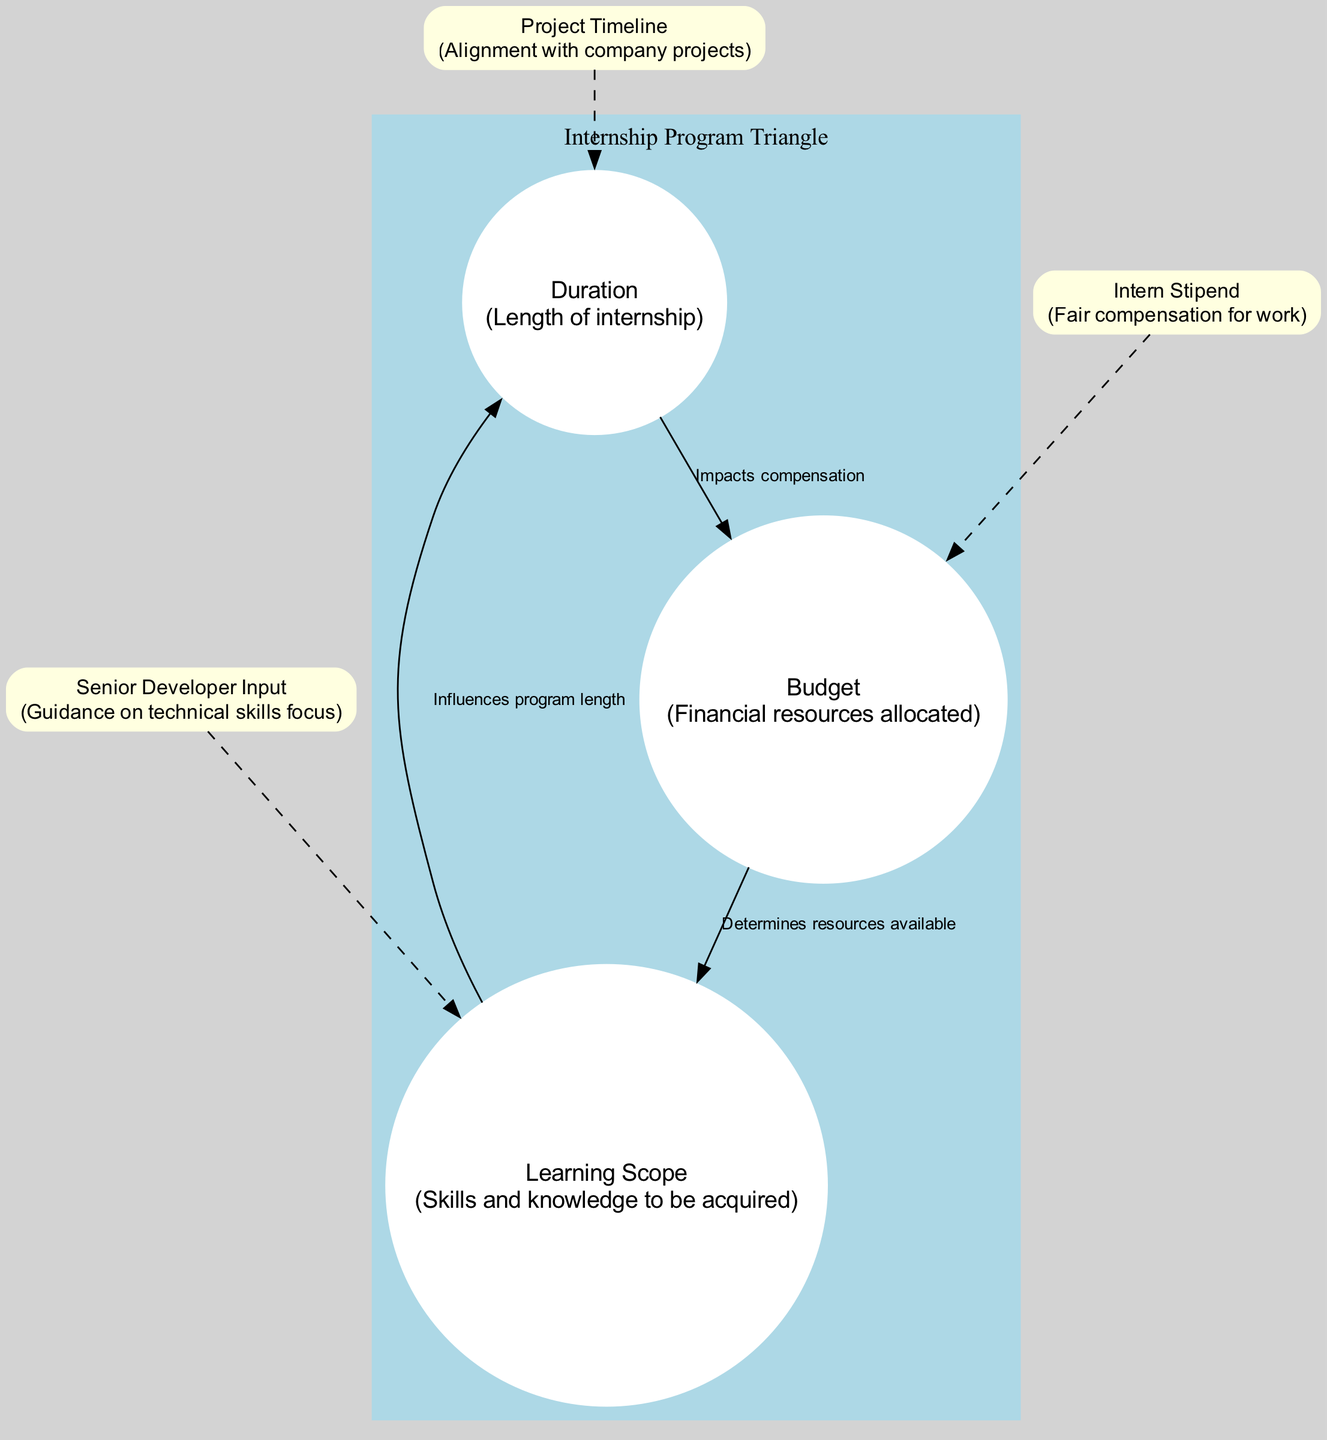What are the three vertices of the diagram? The vertices listed in the diagram are Duration, Budget, and Learning Scope. This is determined by looking at the vertices section of the diagram, which specifically names these elements.
Answer: Duration, Budget, Learning Scope What does the edge from Duration to Budget represent? The edge from Duration to Budget is labeled "Impacts compensation." This indicates the relationship between the length of the internship and how it affects the compensation given.
Answer: Impacts compensation How many edges are there in total? There are three edges shown in the diagram, connecting the vertices to each other as indicated by the edges section.
Answer: 3 What is the connection for the element "Senior Developer Input"? The element "Senior Developer Input" is connected to "Learning Scope," as indicated in the additional elements section of the diagram.
Answer: Learning Scope What influence does Learning Scope have on Duration? Learning Scope influences Duration, which is stated in the edge description linking these two vertices. It indicates that the skills and knowledge to be acquired can affect how long the internship lasts.
Answer: Influences program length Which additional element is connected to Budget? The additional element connected to Budget is "Intern Stipend." This is clearly shown in the additional elements section, where the connection is specified.
Answer: Intern Stipend What is the role of "Project Timeline" in the diagram? "Project Timeline" is connected to "Duration" in the additional elements, suggesting that it plays a role in aligning the internship length with company projects.
Answer: Duration What relationship is indicated between Budget and Learning Scope? The relationship between Budget and Learning Scope is that the Budget determines resources available for the internship program, as stated in the edge representation.
Answer: Determines resources available What is the label of the edge between Budget and Learning Scope? The label of the edge connecting Budget to Learning Scope is "Determines resources available," which defines how financial resources relate to the scope of skills acquired.
Answer: Determines resources available 